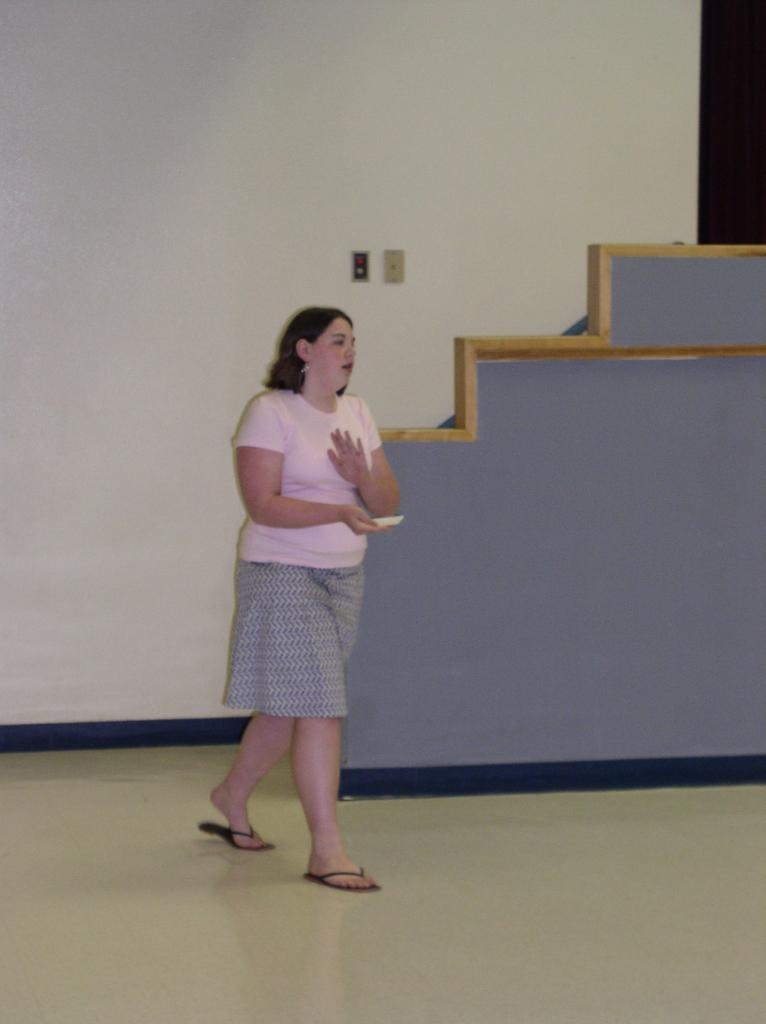Who is present in the image? There is a woman in the image. What is the woman wearing? The woman is wearing a pink top and skirt. What can be seen beneath the woman's feet in the image? The floor is visible in the image. What is the color of the wall in the background of the image? There is a white wall in the background of the image. What is the color or feature of the object in the background of the image? There is a purple object or feature in the background of the image. Can you hear the woman laughing in the image? There is no sound or indication of laughter in the image, as it is a still photograph. 